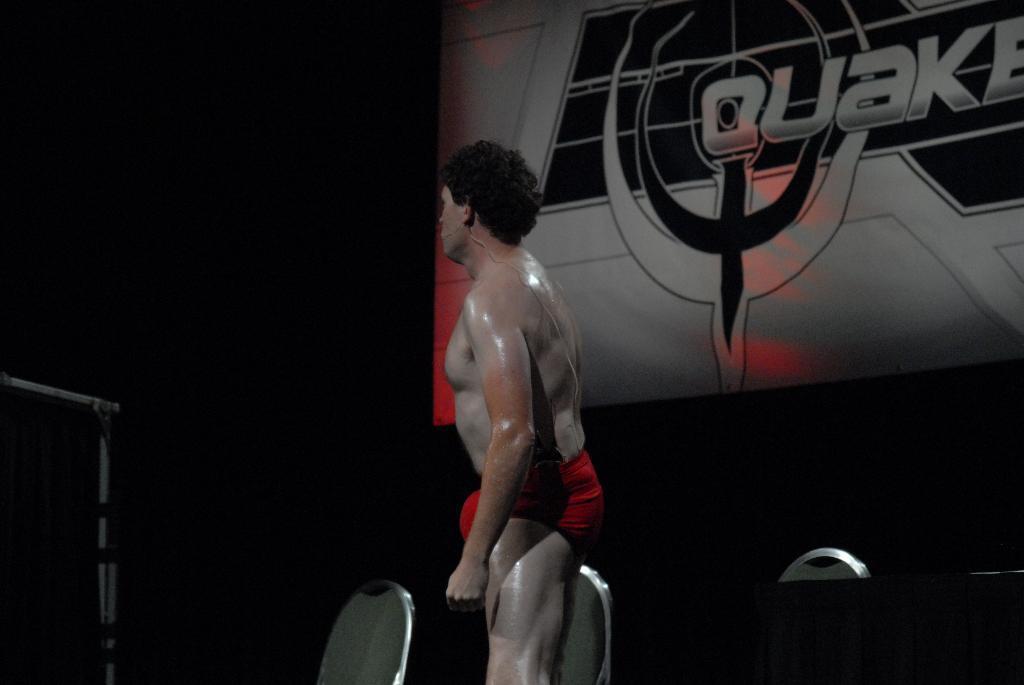How would you summarize this image in a sentence or two? In this image I can see the person standing. To the side of the person I can see the chairs and the board. And there is a black background. 